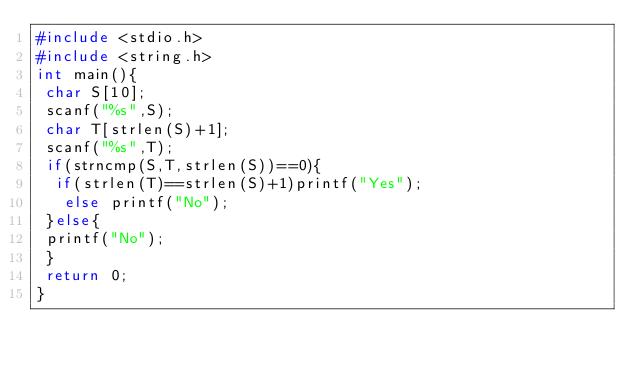Convert code to text. <code><loc_0><loc_0><loc_500><loc_500><_C_>#include <stdio.h>
#include <string.h>
int main(){
 char S[10];
 scanf("%s",S);
 char T[strlen(S)+1];
 scanf("%s",T);
 if(strncmp(S,T,strlen(S))==0){
  if(strlen(T)==strlen(S)+1)printf("Yes");
   else printf("No");
 }else{
 printf("No");
 }
 return 0;
}</code> 